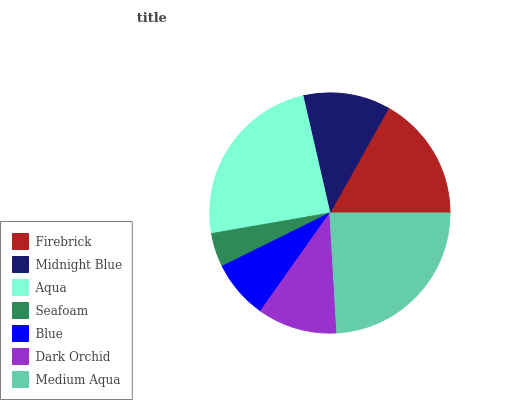Is Seafoam the minimum?
Answer yes or no. Yes. Is Aqua the maximum?
Answer yes or no. Yes. Is Midnight Blue the minimum?
Answer yes or no. No. Is Midnight Blue the maximum?
Answer yes or no. No. Is Firebrick greater than Midnight Blue?
Answer yes or no. Yes. Is Midnight Blue less than Firebrick?
Answer yes or no. Yes. Is Midnight Blue greater than Firebrick?
Answer yes or no. No. Is Firebrick less than Midnight Blue?
Answer yes or no. No. Is Midnight Blue the high median?
Answer yes or no. Yes. Is Midnight Blue the low median?
Answer yes or no. Yes. Is Medium Aqua the high median?
Answer yes or no. No. Is Blue the low median?
Answer yes or no. No. 